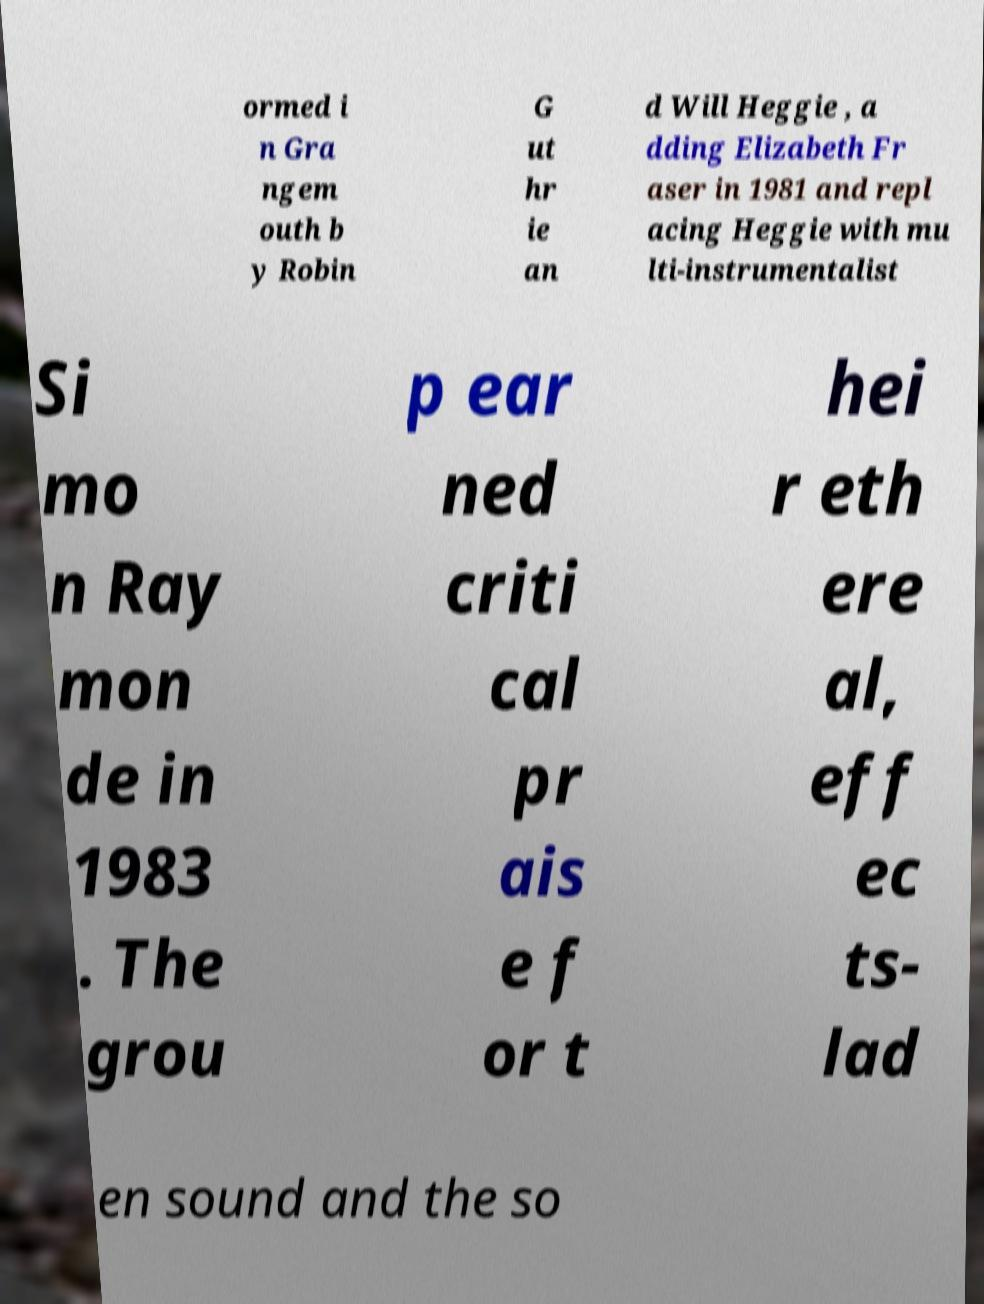Could you assist in decoding the text presented in this image and type it out clearly? ormed i n Gra ngem outh b y Robin G ut hr ie an d Will Heggie , a dding Elizabeth Fr aser in 1981 and repl acing Heggie with mu lti-instrumentalist Si mo n Ray mon de in 1983 . The grou p ear ned criti cal pr ais e f or t hei r eth ere al, eff ec ts- lad en sound and the so 